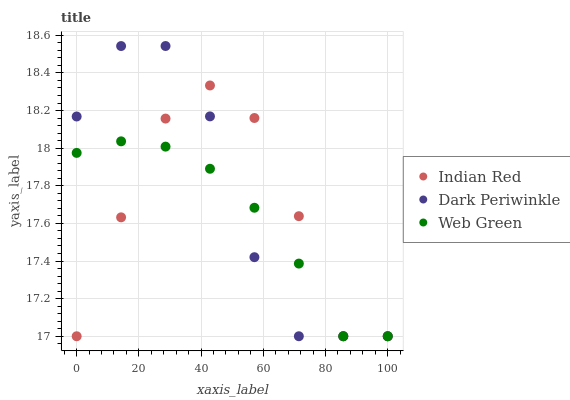Does Web Green have the minimum area under the curve?
Answer yes or no. Yes. Does Dark Periwinkle have the maximum area under the curve?
Answer yes or no. Yes. Does Indian Red have the minimum area under the curve?
Answer yes or no. No. Does Indian Red have the maximum area under the curve?
Answer yes or no. No. Is Web Green the smoothest?
Answer yes or no. Yes. Is Indian Red the roughest?
Answer yes or no. Yes. Is Dark Periwinkle the smoothest?
Answer yes or no. No. Is Dark Periwinkle the roughest?
Answer yes or no. No. Does Web Green have the lowest value?
Answer yes or no. Yes. Does Dark Periwinkle have the highest value?
Answer yes or no. Yes. Does Indian Red have the highest value?
Answer yes or no. No. Does Web Green intersect Indian Red?
Answer yes or no. Yes. Is Web Green less than Indian Red?
Answer yes or no. No. Is Web Green greater than Indian Red?
Answer yes or no. No. 